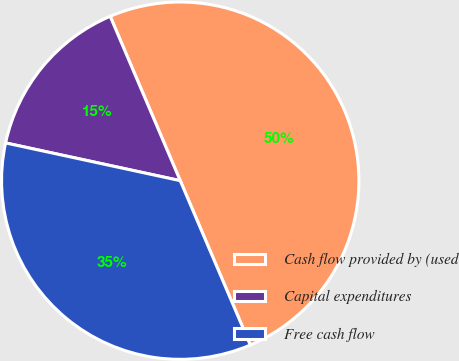Convert chart to OTSL. <chart><loc_0><loc_0><loc_500><loc_500><pie_chart><fcel>Cash flow provided by (used<fcel>Capital expenditures<fcel>Free cash flow<nl><fcel>50.0%<fcel>15.2%<fcel>34.8%<nl></chart> 